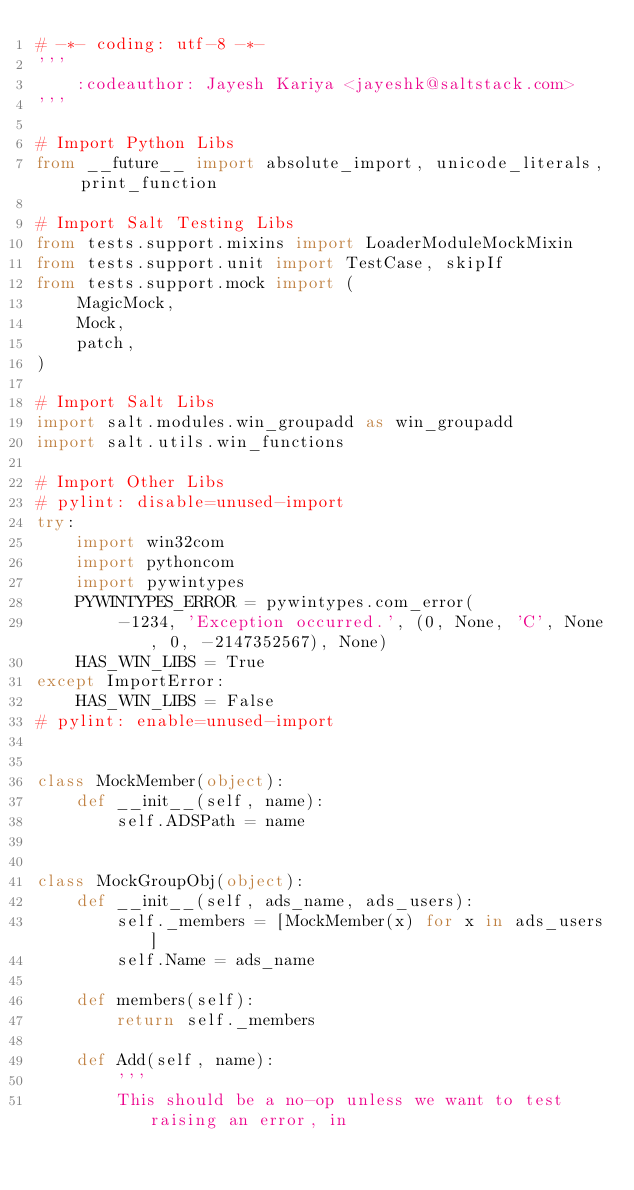<code> <loc_0><loc_0><loc_500><loc_500><_Python_># -*- coding: utf-8 -*-
'''
    :codeauthor: Jayesh Kariya <jayeshk@saltstack.com>
'''

# Import Python Libs
from __future__ import absolute_import, unicode_literals, print_function

# Import Salt Testing Libs
from tests.support.mixins import LoaderModuleMockMixin
from tests.support.unit import TestCase, skipIf
from tests.support.mock import (
    MagicMock,
    Mock,
    patch,
)

# Import Salt Libs
import salt.modules.win_groupadd as win_groupadd
import salt.utils.win_functions

# Import Other Libs
# pylint: disable=unused-import
try:
    import win32com
    import pythoncom
    import pywintypes
    PYWINTYPES_ERROR = pywintypes.com_error(
        -1234, 'Exception occurred.', (0, None, 'C', None, 0, -2147352567), None)
    HAS_WIN_LIBS = True
except ImportError:
    HAS_WIN_LIBS = False
# pylint: enable=unused-import


class MockMember(object):
    def __init__(self, name):
        self.ADSPath = name


class MockGroupObj(object):
    def __init__(self, ads_name, ads_users):
        self._members = [MockMember(x) for x in ads_users]
        self.Name = ads_name

    def members(self):
        return self._members

    def Add(self, name):
        '''
        This should be a no-op unless we want to test raising an error, in</code> 